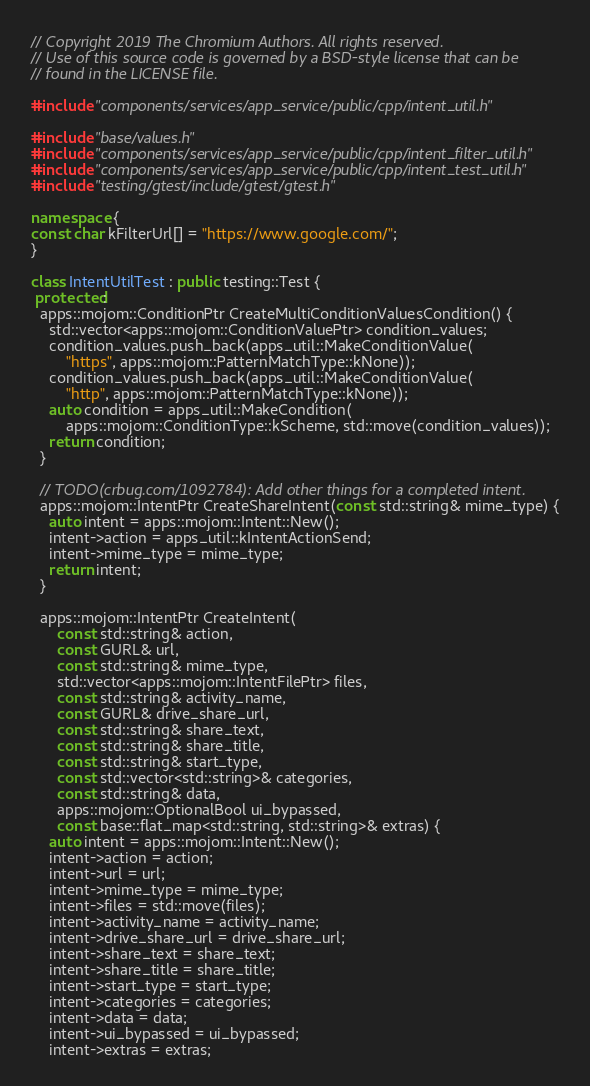Convert code to text. <code><loc_0><loc_0><loc_500><loc_500><_C++_>// Copyright 2019 The Chromium Authors. All rights reserved.
// Use of this source code is governed by a BSD-style license that can be
// found in the LICENSE file.

#include "components/services/app_service/public/cpp/intent_util.h"

#include "base/values.h"
#include "components/services/app_service/public/cpp/intent_filter_util.h"
#include "components/services/app_service/public/cpp/intent_test_util.h"
#include "testing/gtest/include/gtest/gtest.h"

namespace {
const char kFilterUrl[] = "https://www.google.com/";
}

class IntentUtilTest : public testing::Test {
 protected:
  apps::mojom::ConditionPtr CreateMultiConditionValuesCondition() {
    std::vector<apps::mojom::ConditionValuePtr> condition_values;
    condition_values.push_back(apps_util::MakeConditionValue(
        "https", apps::mojom::PatternMatchType::kNone));
    condition_values.push_back(apps_util::MakeConditionValue(
        "http", apps::mojom::PatternMatchType::kNone));
    auto condition = apps_util::MakeCondition(
        apps::mojom::ConditionType::kScheme, std::move(condition_values));
    return condition;
  }

  // TODO(crbug.com/1092784): Add other things for a completed intent.
  apps::mojom::IntentPtr CreateShareIntent(const std::string& mime_type) {
    auto intent = apps::mojom::Intent::New();
    intent->action = apps_util::kIntentActionSend;
    intent->mime_type = mime_type;
    return intent;
  }

  apps::mojom::IntentPtr CreateIntent(
      const std::string& action,
      const GURL& url,
      const std::string& mime_type,
      std::vector<apps::mojom::IntentFilePtr> files,
      const std::string& activity_name,
      const GURL& drive_share_url,
      const std::string& share_text,
      const std::string& share_title,
      const std::string& start_type,
      const std::vector<std::string>& categories,
      const std::string& data,
      apps::mojom::OptionalBool ui_bypassed,
      const base::flat_map<std::string, std::string>& extras) {
    auto intent = apps::mojom::Intent::New();
    intent->action = action;
    intent->url = url;
    intent->mime_type = mime_type;
    intent->files = std::move(files);
    intent->activity_name = activity_name;
    intent->drive_share_url = drive_share_url;
    intent->share_text = share_text;
    intent->share_title = share_title;
    intent->start_type = start_type;
    intent->categories = categories;
    intent->data = data;
    intent->ui_bypassed = ui_bypassed;
    intent->extras = extras;</code> 